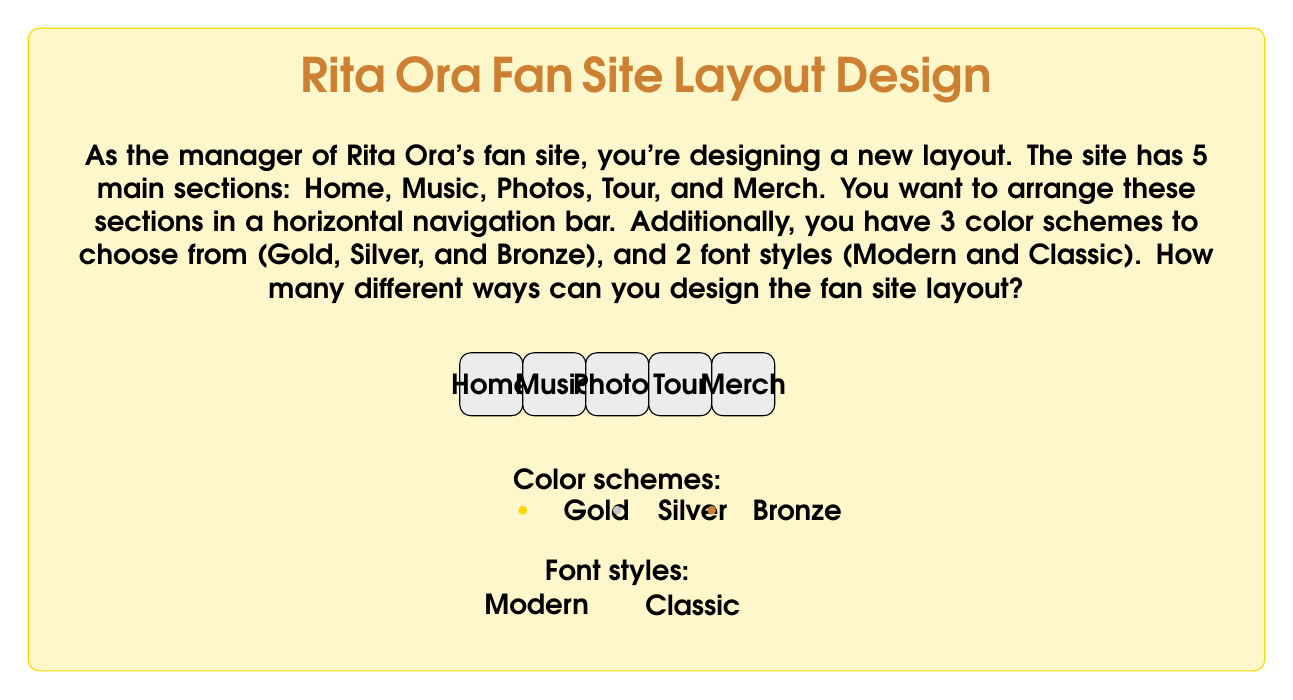Give your solution to this math problem. To solve this problem, we need to use the multiplication principle of combinatorics. We'll break down the problem into its components:

1. Arrangement of sections:
   We have 5 sections to arrange in a horizontal bar. This is a permutation of 5 items, which can be calculated as:
   $$5! = 5 \times 4 \times 3 \times 2 \times 1 = 120$$

2. Color schemes:
   There are 3 color schemes to choose from.

3. Font styles:
   There are 2 font styles to choose from.

Now, we apply the multiplication principle. For each arrangement of sections, we can choose any of the 3 color schemes, and for each of these combinations, we can choose either of the 2 font styles.

Therefore, the total number of possible layouts is:

$$120 \times 3 \times 2 = 720$$

This calculation gives us the total number of unique combinations of section arrangements, color schemes, and font styles for the fan site layout.
Answer: 720 possible layouts 